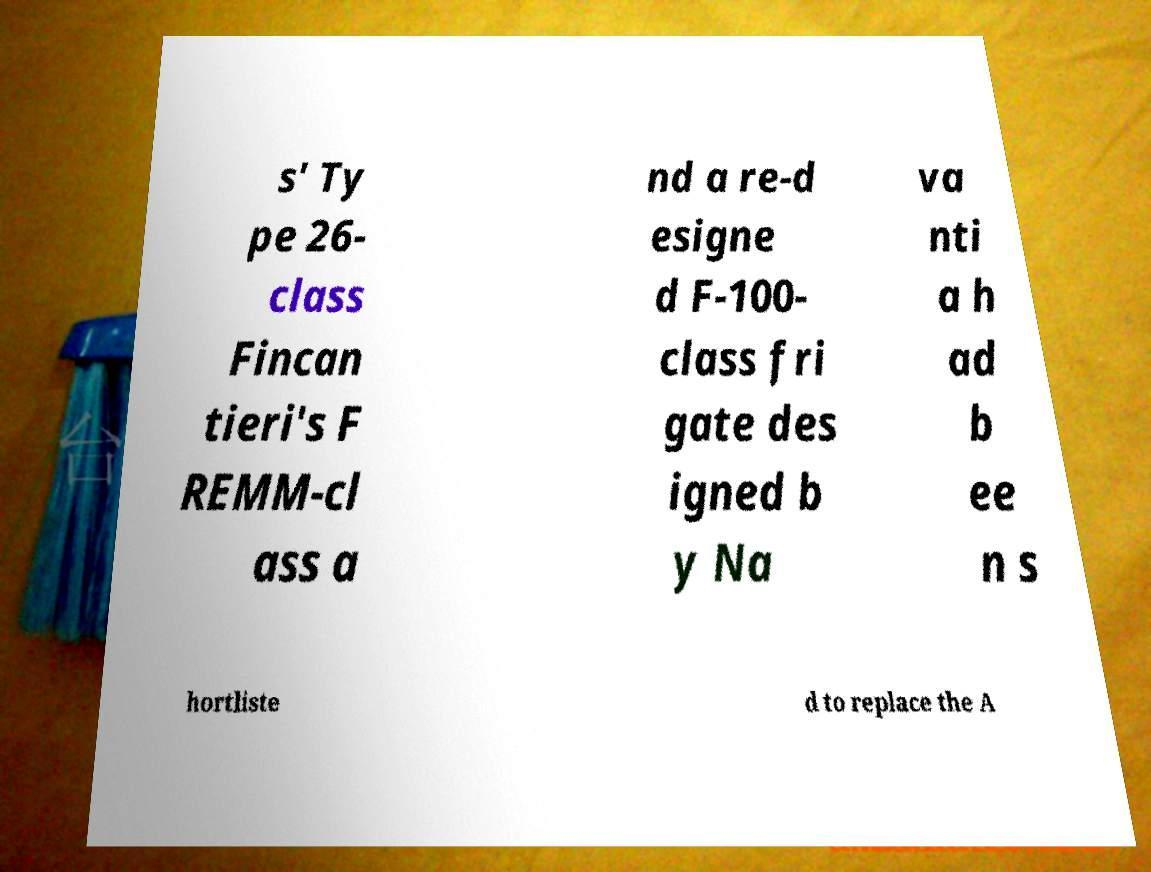I need the written content from this picture converted into text. Can you do that? s' Ty pe 26- class Fincan tieri's F REMM-cl ass a nd a re-d esigne d F-100- class fri gate des igned b y Na va nti a h ad b ee n s hortliste d to replace the A 